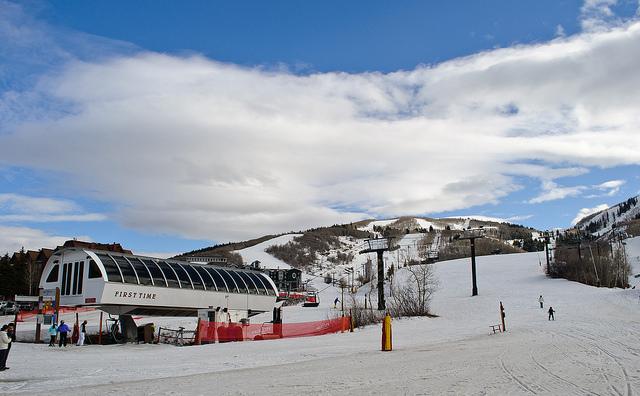What is in the picture?
Write a very short answer. Snow. Is this picture taken at a ski resort?
Give a very brief answer. Yes. What shape is the building on the left?
Answer briefly. Curved. What are the first three letters on the building?
Give a very brief answer. Fir. Is there a train in this photo?
Keep it brief. No. Are the skies clear?
Answer briefly. No. 